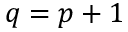<formula> <loc_0><loc_0><loc_500><loc_500>q = p + 1</formula> 